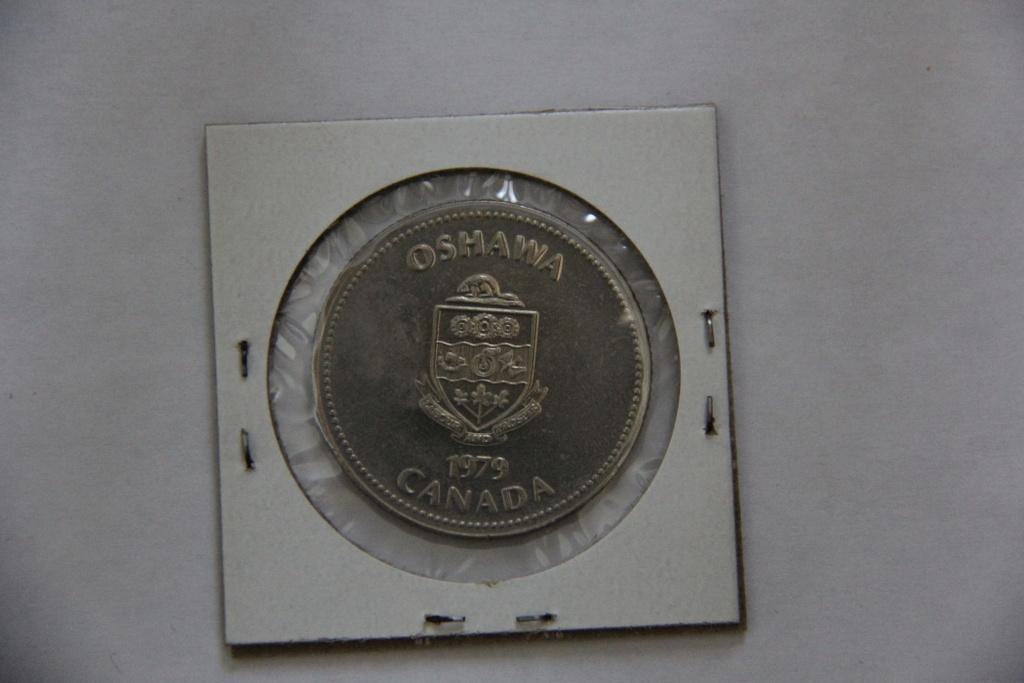<image>
Describe the image concisely. A coin from canda with the name of Oshawa on top. 